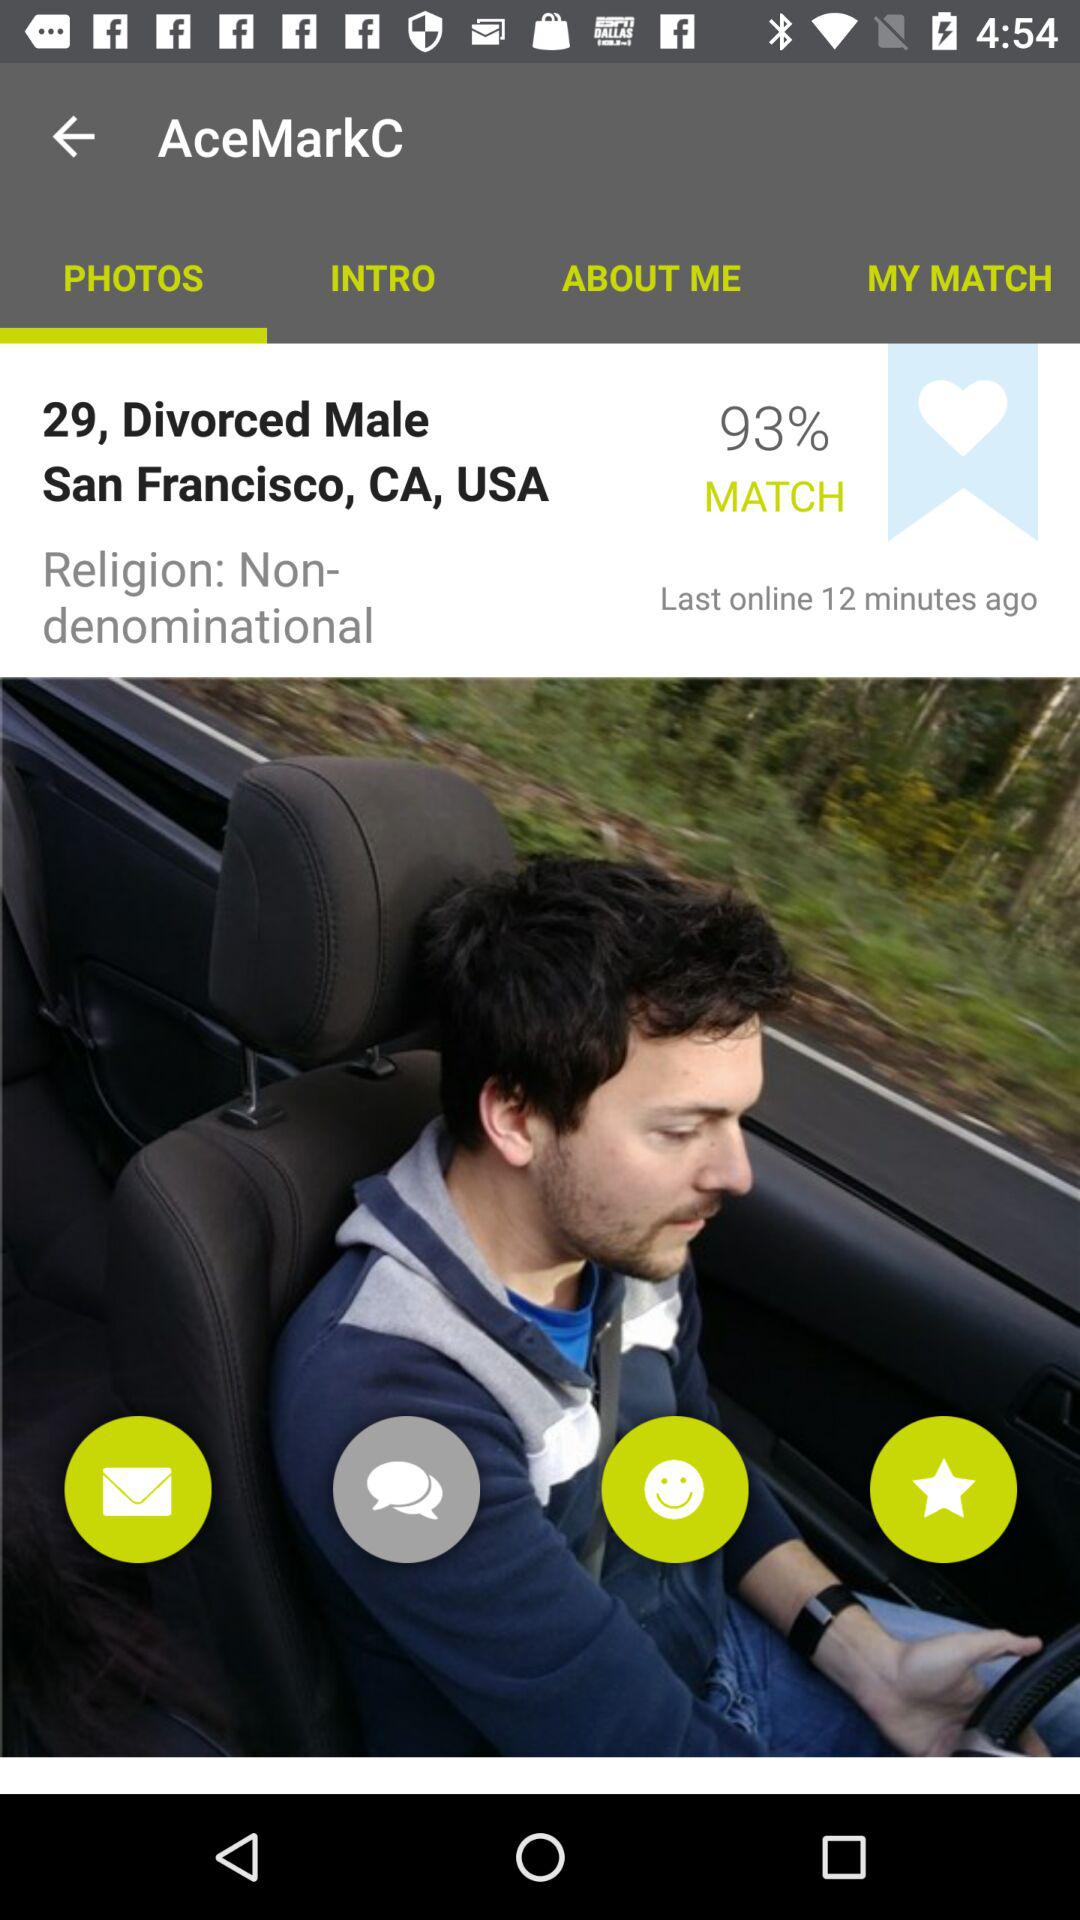Which tab is selected? The selected tab is "PHOTOS". 